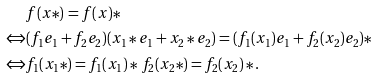Convert formula to latex. <formula><loc_0><loc_0><loc_500><loc_500>\, & f ( x * ) = f ( x ) * \\ \Leftrightarrow & ( f _ { 1 } e _ { 1 } + f _ { 2 } e _ { 2 } ) ( x _ { 1 } * e _ { 1 } + x _ { 2 } * e _ { 2 } ) = ( f _ { 1 } ( x _ { 1 } ) e _ { 1 } + f _ { 2 } ( x _ { 2 } ) e _ { 2 } ) * \\ \Leftrightarrow & f _ { 1 } ( x _ { 1 } * ) = f _ { 1 } ( x _ { 1 } ) * \, f _ { 2 } ( x _ { 2 } * ) = f _ { 2 } ( x _ { 2 } ) * .</formula> 